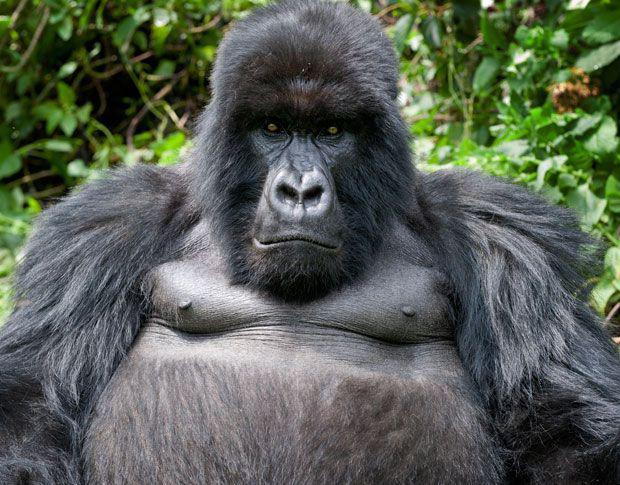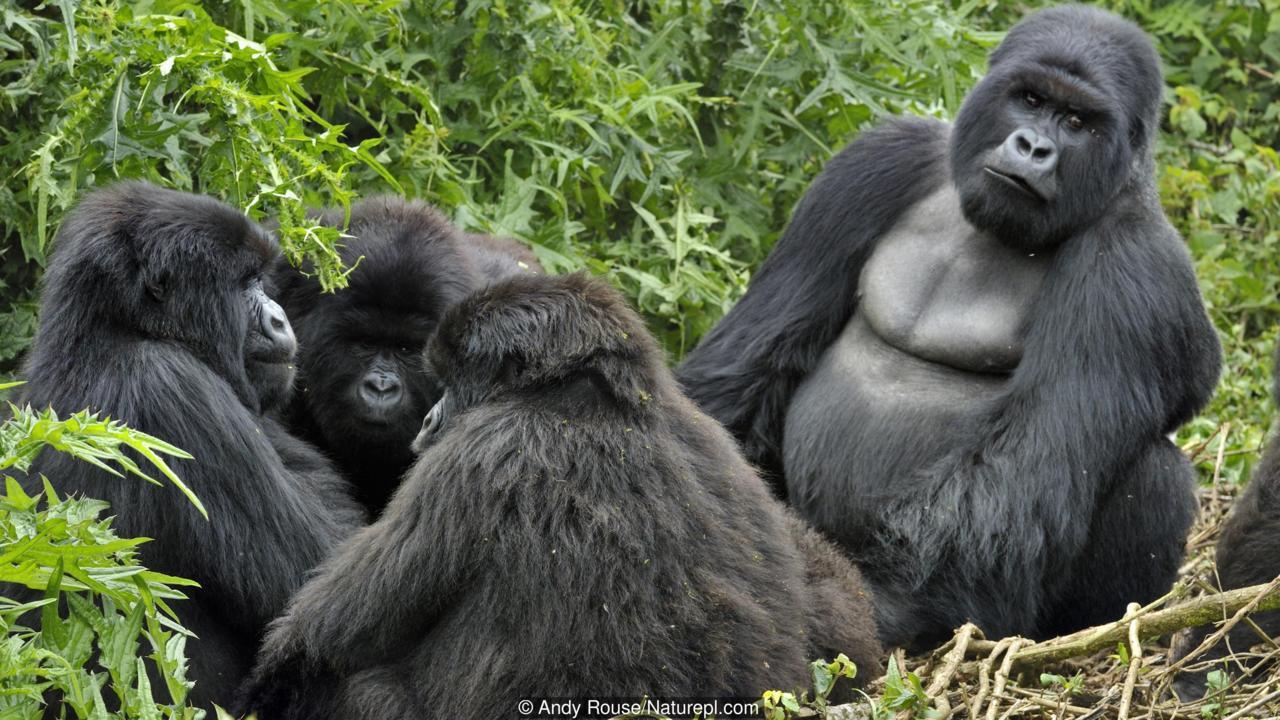The first image is the image on the left, the second image is the image on the right. Considering the images on both sides, is "The right image shows curled gray fingers pointing toward the head of a forward-facing baby gorilla." valid? Answer yes or no. No. The first image is the image on the left, the second image is the image on the right. Assess this claim about the two images: "In at least one image there are two gorillas with one adult holding a single baby.". Correct or not? Answer yes or no. No. 